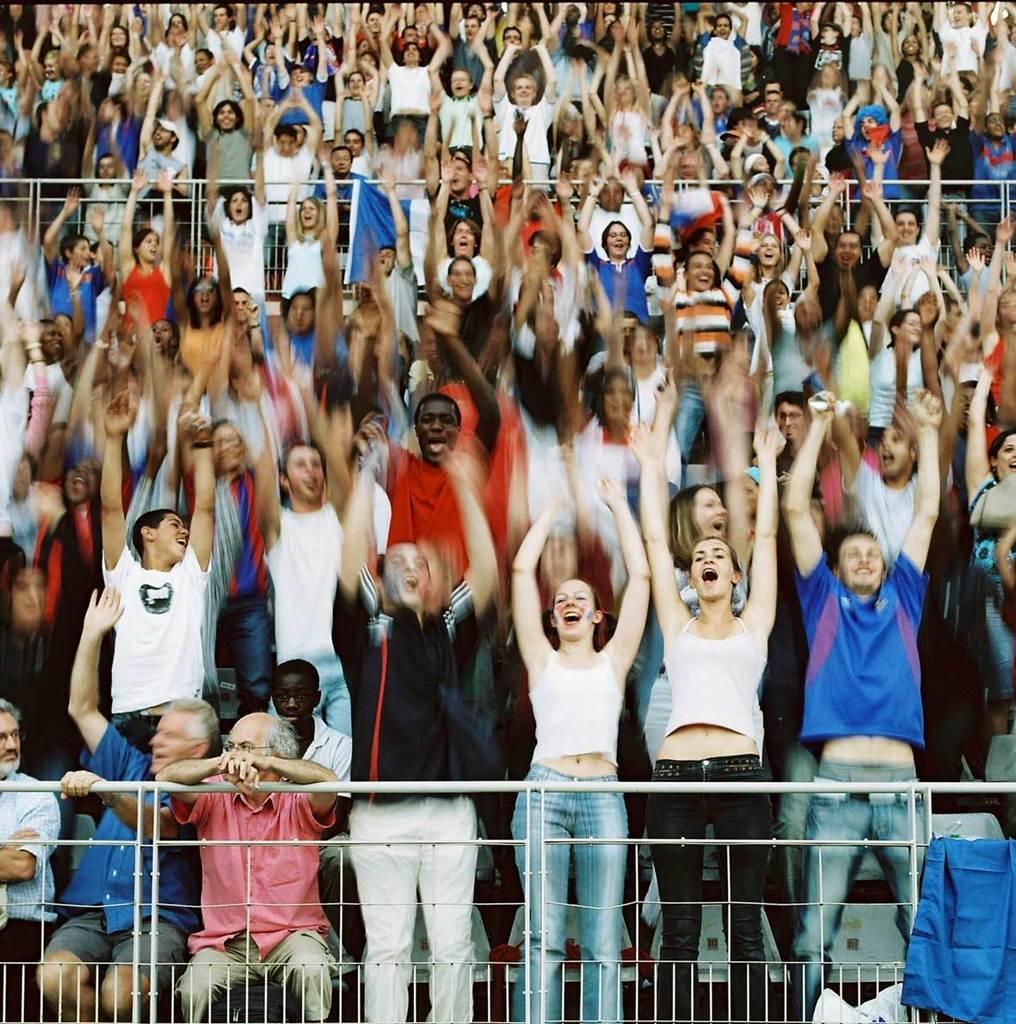How would you summarize this image in a sentence or two? In this picture we can see some people are standing on the path and some people are sitting on chairs. In between the people there are iron grills and a banner. 